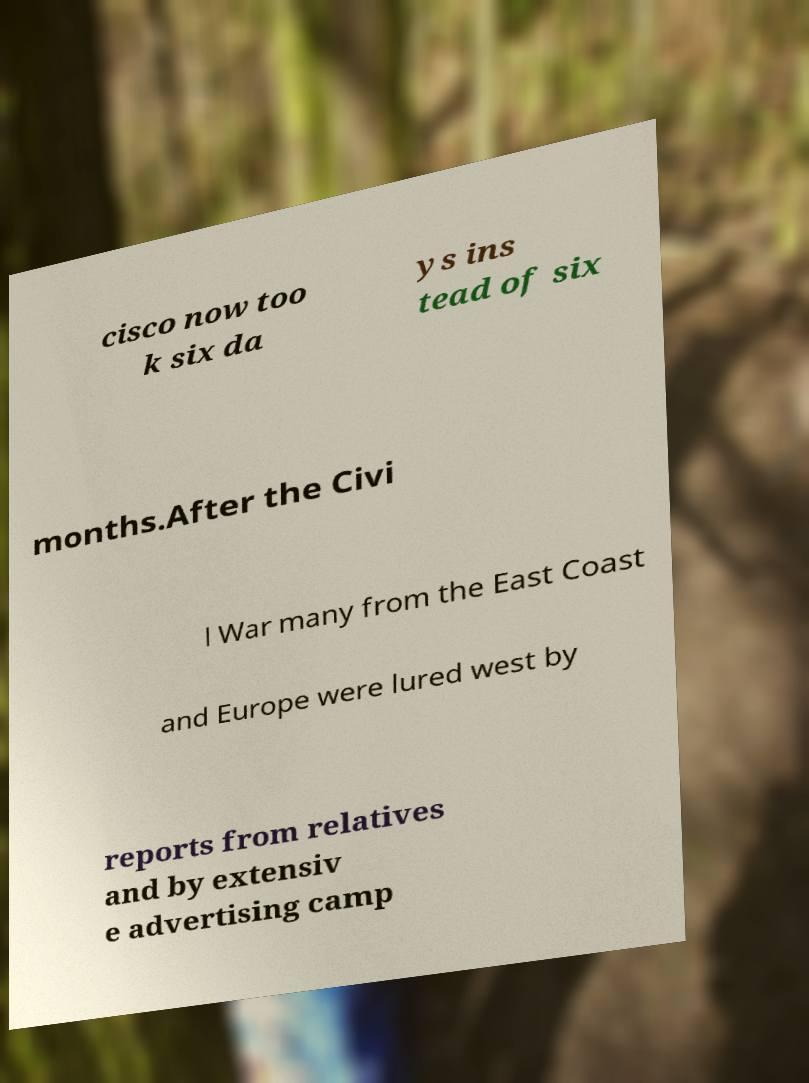Please read and relay the text visible in this image. What does it say? cisco now too k six da ys ins tead of six months.After the Civi l War many from the East Coast and Europe were lured west by reports from relatives and by extensiv e advertising camp 